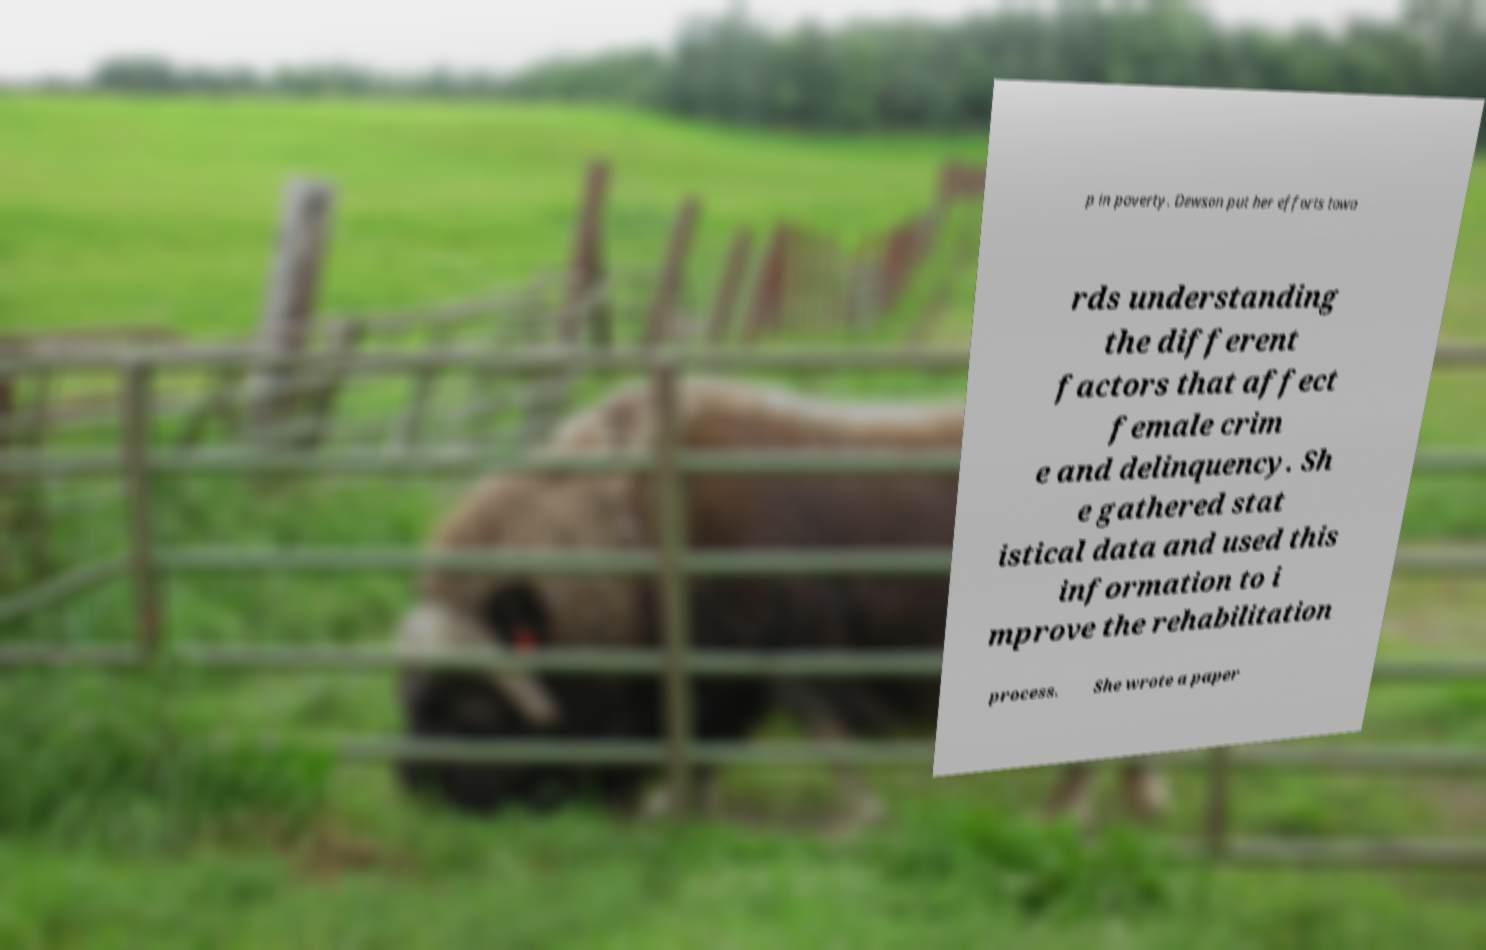Could you assist in decoding the text presented in this image and type it out clearly? p in poverty. Dewson put her efforts towa rds understanding the different factors that affect female crim e and delinquency. Sh e gathered stat istical data and used this information to i mprove the rehabilitation process. She wrote a paper 